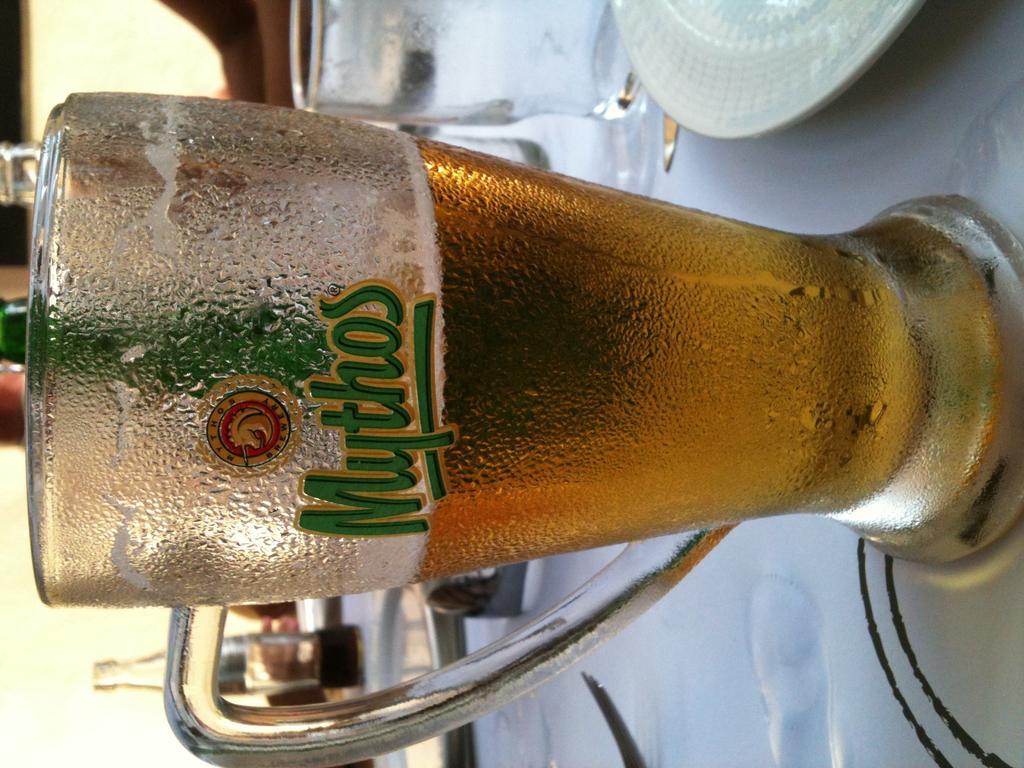In one or two sentences, can you explain what this image depicts? In this picture we can see a plate, glasses, bottles, fork and these all are placed on tables and in the background we can see some objects. 